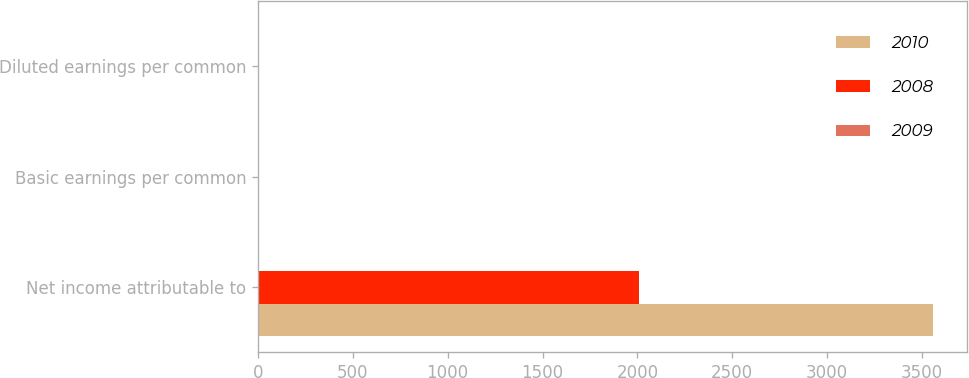<chart> <loc_0><loc_0><loc_500><loc_500><stacked_bar_chart><ecel><fcel>Net income attributable to<fcel>Basic earnings per common<fcel>Diluted earnings per common<nl><fcel>2010<fcel>3558<fcel>2.28<fcel>2.25<nl><fcel>2008<fcel>2008<fcel>1.3<fcel>1.28<nl><fcel>2009<fcel>2.8<fcel>3.37<fcel>3.32<nl></chart> 